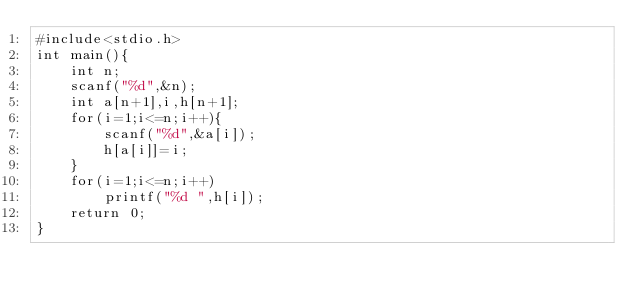Convert code to text. <code><loc_0><loc_0><loc_500><loc_500><_C_>#include<stdio.h>
int main(){
    int n;
    scanf("%d",&n);
    int a[n+1],i,h[n+1];
    for(i=1;i<=n;i++){
        scanf("%d",&a[i]);
        h[a[i]]=i;
    }
    for(i=1;i<=n;i++)
        printf("%d ",h[i]);
    return 0;
}</code> 